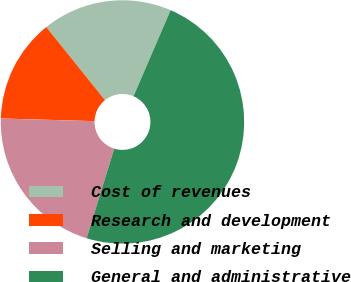Convert chart to OTSL. <chart><loc_0><loc_0><loc_500><loc_500><pie_chart><fcel>Cost of revenues<fcel>Research and development<fcel>Selling and marketing<fcel>General and administrative<nl><fcel>17.24%<fcel>13.78%<fcel>20.69%<fcel>48.29%<nl></chart> 